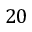<formula> <loc_0><loc_0><loc_500><loc_500>2 0</formula> 